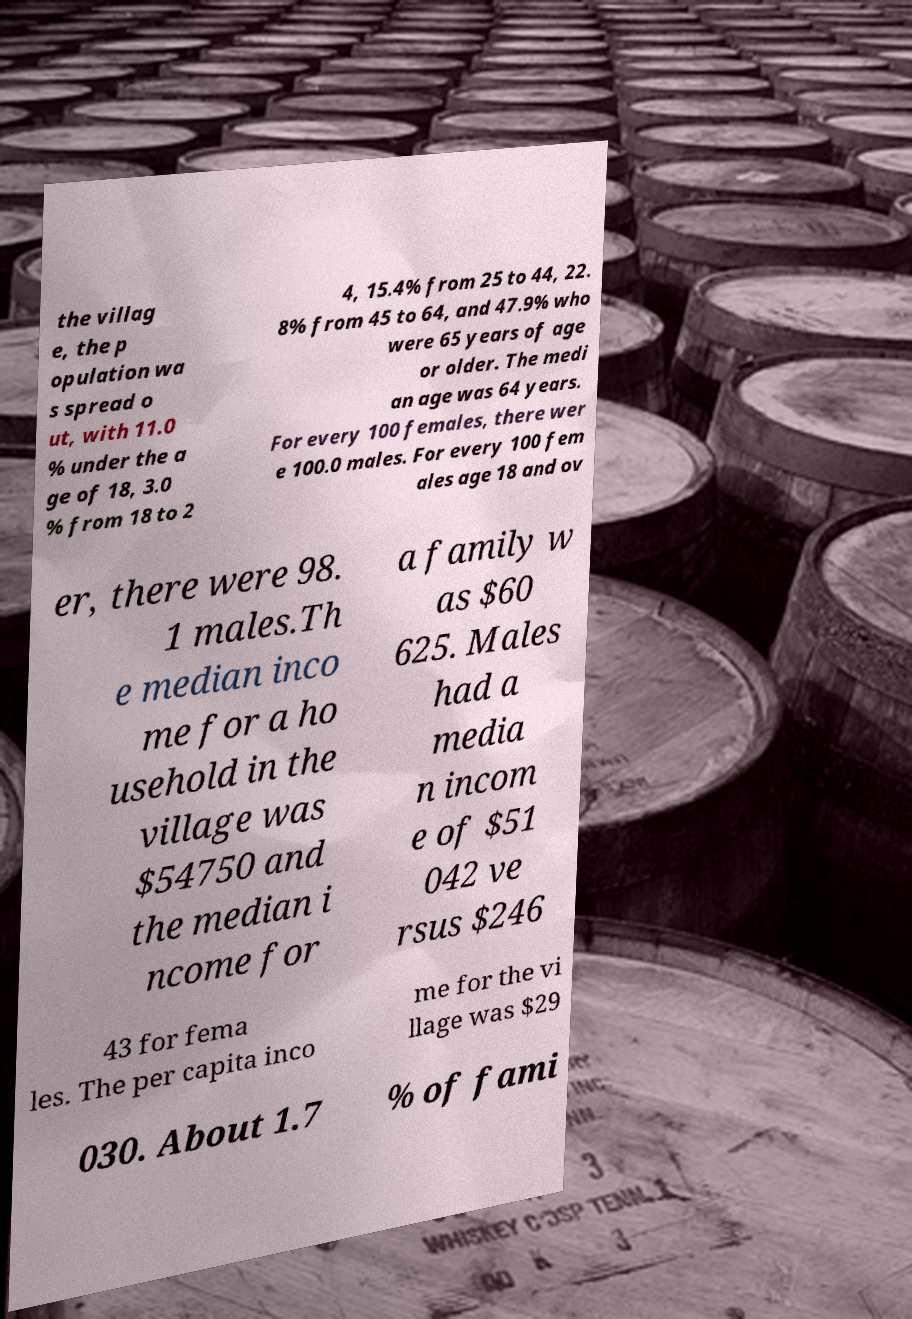For documentation purposes, I need the text within this image transcribed. Could you provide that? the villag e, the p opulation wa s spread o ut, with 11.0 % under the a ge of 18, 3.0 % from 18 to 2 4, 15.4% from 25 to 44, 22. 8% from 45 to 64, and 47.9% who were 65 years of age or older. The medi an age was 64 years. For every 100 females, there wer e 100.0 males. For every 100 fem ales age 18 and ov er, there were 98. 1 males.Th e median inco me for a ho usehold in the village was $54750 and the median i ncome for a family w as $60 625. Males had a media n incom e of $51 042 ve rsus $246 43 for fema les. The per capita inco me for the vi llage was $29 030. About 1.7 % of fami 